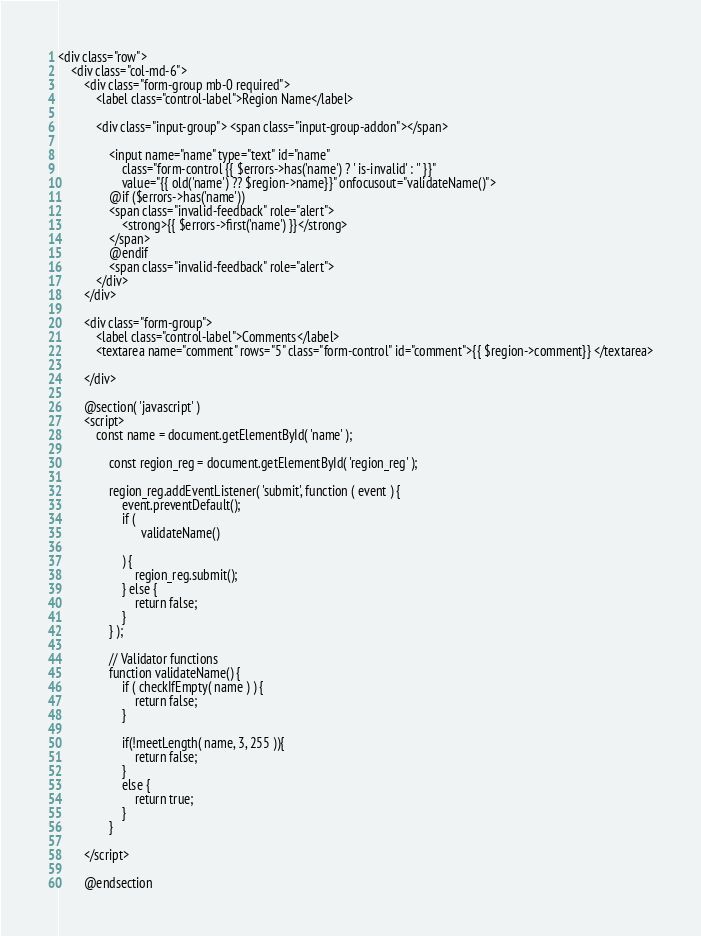Convert code to text. <code><loc_0><loc_0><loc_500><loc_500><_PHP_><div class="row">
    <div class="col-md-6">
        <div class="form-group mb-0 required">
            <label class="control-label">Region Name</label>

            <div class="input-group"> <span class="input-group-addon"></span>

                <input name="name" type="text" id="name"
                    class="form-control {{ $errors->has('name') ? ' is-invalid' : '' }}"
                    value="{{ old('name') ?? $region->name}}" onfocusout="validateName()">
                @if ($errors->has('name'))
                <span class="invalid-feedback" role="alert">
                    <strong>{{ $errors->first('name') }}</strong>
                </span>
                @endif
                <span class="invalid-feedback" role="alert">
            </div>
        </div>

        <div class="form-group">
            <label class="control-label">Comments</label>
            <textarea name="comment" rows="5" class="form-control" id="comment">{{ $region->comment}} </textarea>

        </div>

        @section( 'javascript' )
        <script>
            const name = document.getElementById( 'name' );
                
                const region_reg = document.getElementById( 'region_reg' );
            
                region_reg.addEventListener( 'submit', function ( event ) {
                    event.preventDefault();
                    if (
                          validateName()
                    
                    ) {
                        region_reg.submit();
                    } else {
                        return false;
                    }
                } );

                // Validator functions
                function validateName() {
                    if ( checkIfEmpty( name ) ) {
                        return false;
                    }
                  
                    if(!meetLength( name, 3, 255 )){
                        return false;
                    }
                    else {
                        return true;
                    }
                }
              
        </script>

        @endsection</code> 